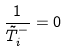<formula> <loc_0><loc_0><loc_500><loc_500>\frac { 1 } { \tilde { T } _ { i } ^ { - } } = 0</formula> 